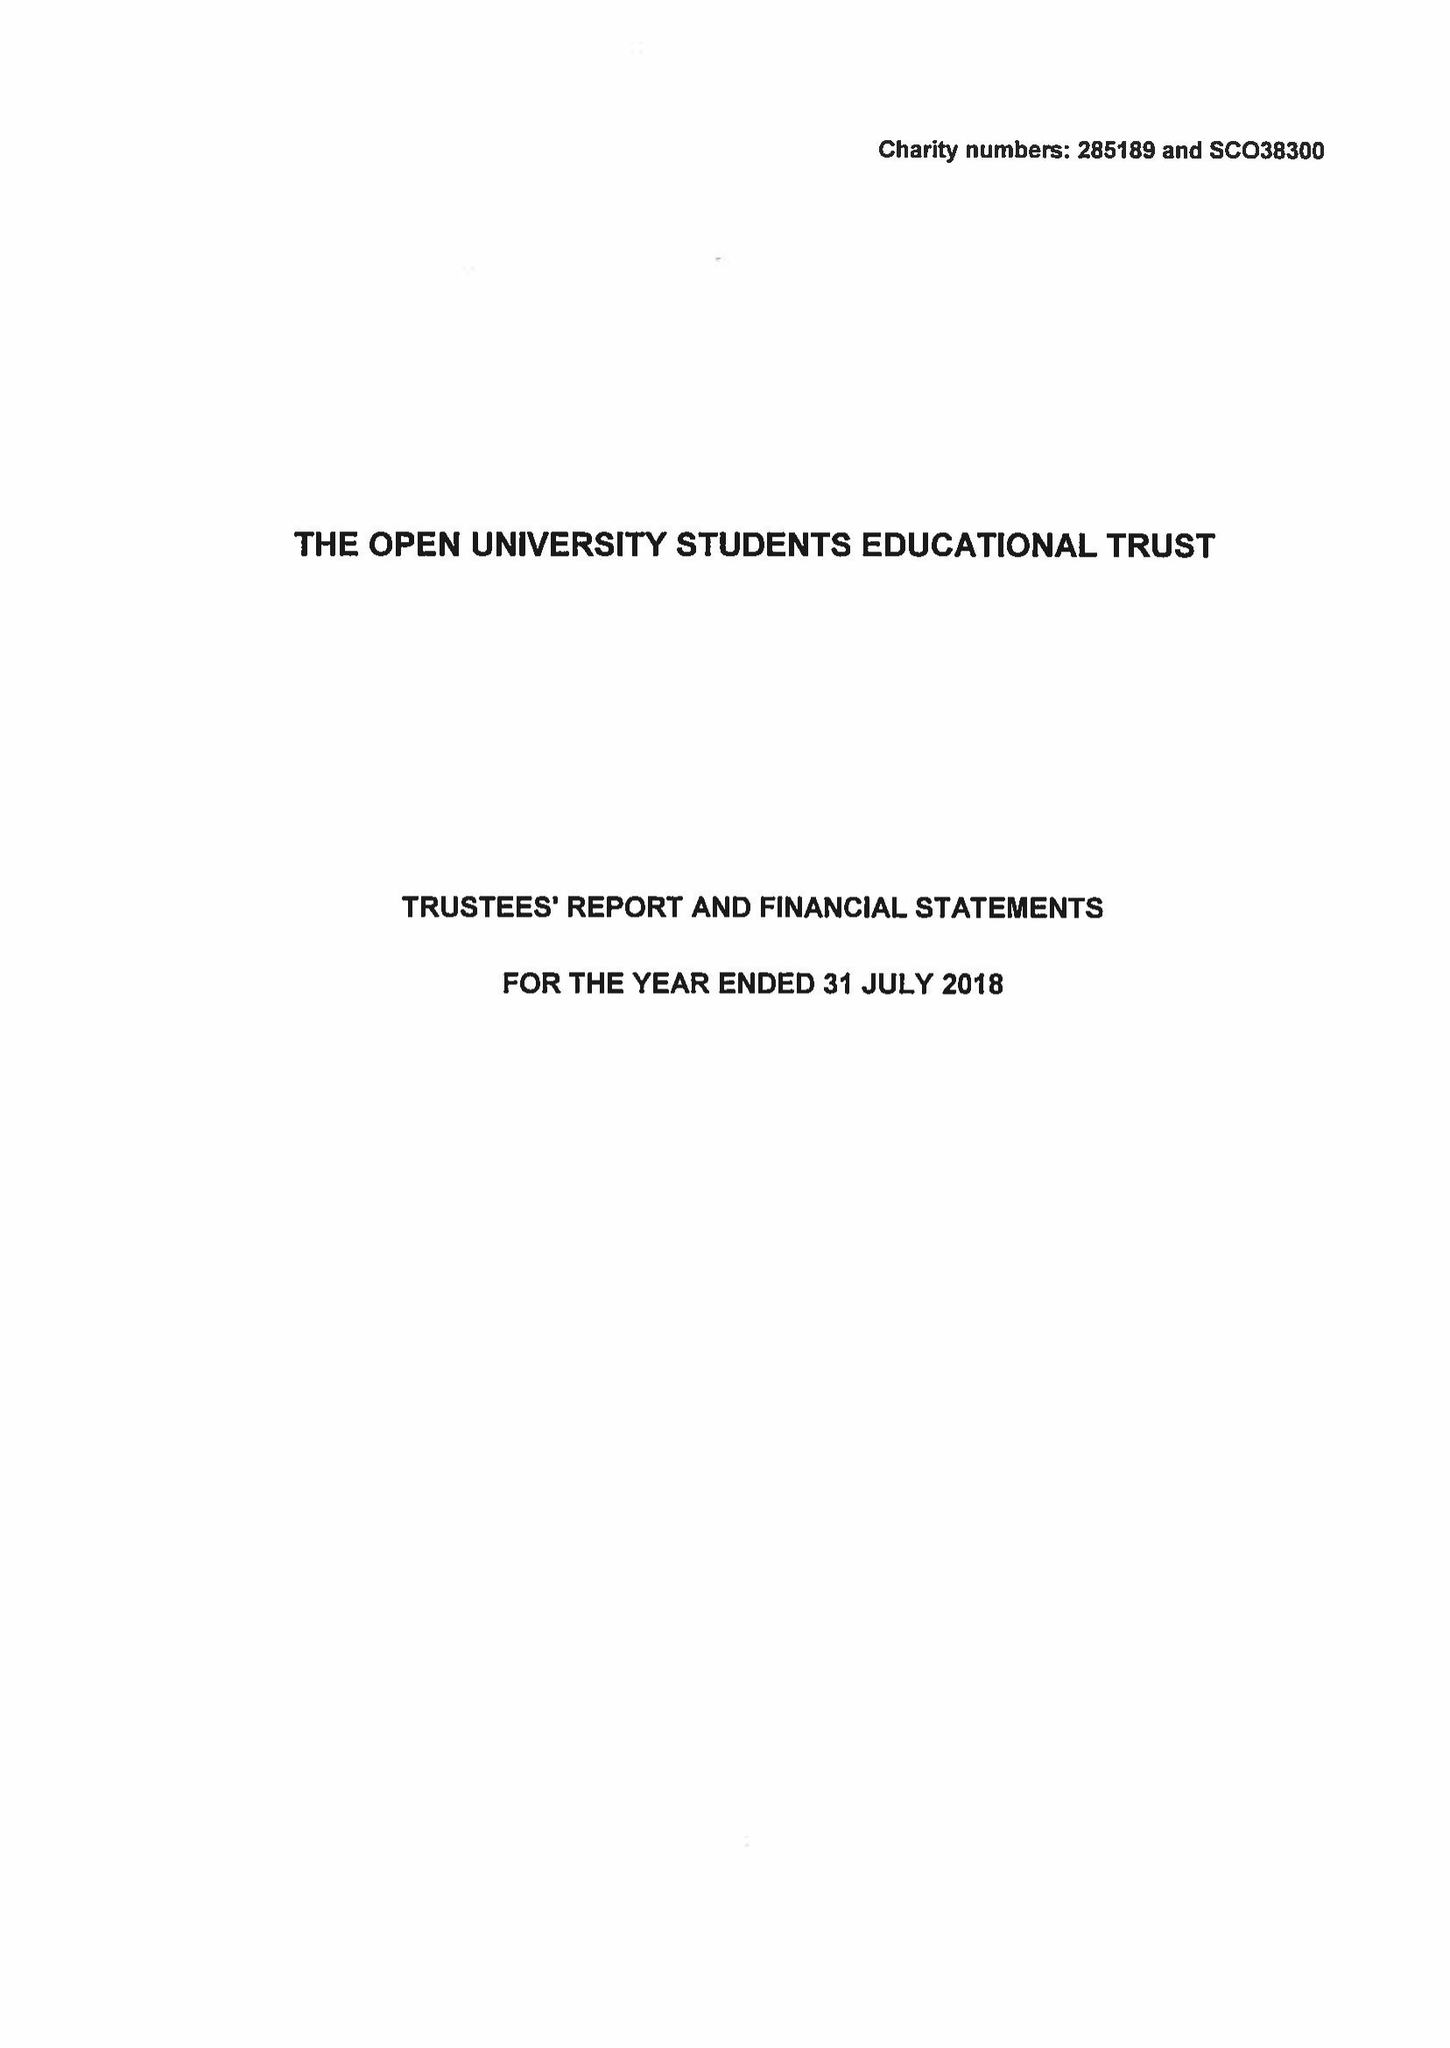What is the value for the address__street_line?
Answer the question using a single word or phrase. PO BOX 397 